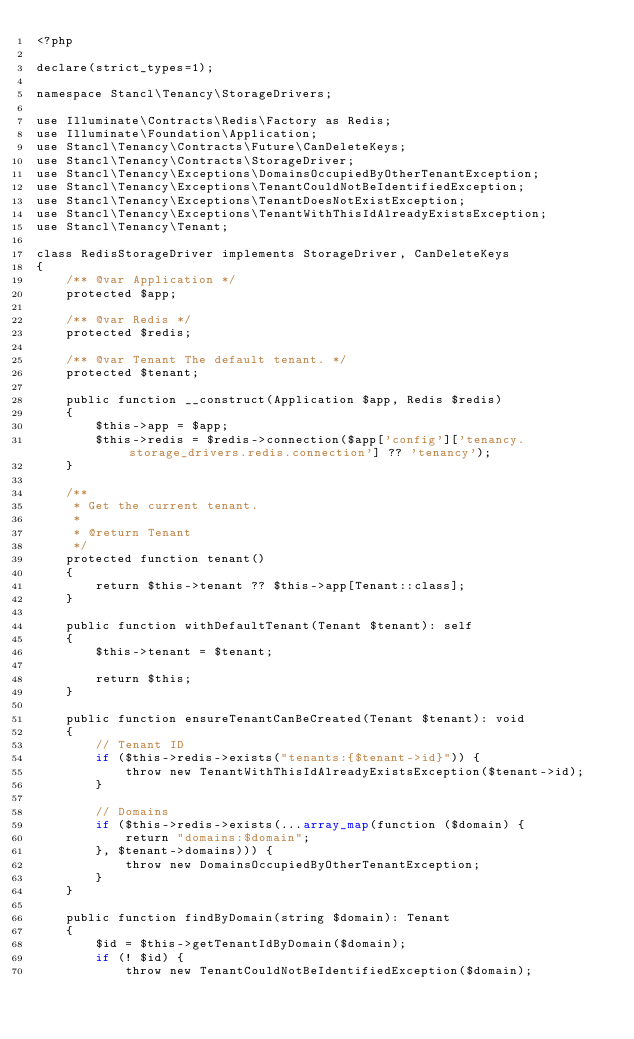<code> <loc_0><loc_0><loc_500><loc_500><_PHP_><?php

declare(strict_types=1);

namespace Stancl\Tenancy\StorageDrivers;

use Illuminate\Contracts\Redis\Factory as Redis;
use Illuminate\Foundation\Application;
use Stancl\Tenancy\Contracts\Future\CanDeleteKeys;
use Stancl\Tenancy\Contracts\StorageDriver;
use Stancl\Tenancy\Exceptions\DomainsOccupiedByOtherTenantException;
use Stancl\Tenancy\Exceptions\TenantCouldNotBeIdentifiedException;
use Stancl\Tenancy\Exceptions\TenantDoesNotExistException;
use Stancl\Tenancy\Exceptions\TenantWithThisIdAlreadyExistsException;
use Stancl\Tenancy\Tenant;

class RedisStorageDriver implements StorageDriver, CanDeleteKeys
{
    /** @var Application */
    protected $app;

    /** @var Redis */
    protected $redis;

    /** @var Tenant The default tenant. */
    protected $tenant;

    public function __construct(Application $app, Redis $redis)
    {
        $this->app = $app;
        $this->redis = $redis->connection($app['config']['tenancy.storage_drivers.redis.connection'] ?? 'tenancy');
    }

    /**
     * Get the current tenant.
     *
     * @return Tenant
     */
    protected function tenant()
    {
        return $this->tenant ?? $this->app[Tenant::class];
    }

    public function withDefaultTenant(Tenant $tenant): self
    {
        $this->tenant = $tenant;

        return $this;
    }

    public function ensureTenantCanBeCreated(Tenant $tenant): void
    {
        // Tenant ID
        if ($this->redis->exists("tenants:{$tenant->id}")) {
            throw new TenantWithThisIdAlreadyExistsException($tenant->id);
        }

        // Domains
        if ($this->redis->exists(...array_map(function ($domain) {
            return "domains:$domain";
        }, $tenant->domains))) {
            throw new DomainsOccupiedByOtherTenantException;
        }
    }

    public function findByDomain(string $domain): Tenant
    {
        $id = $this->getTenantIdByDomain($domain);
        if (! $id) {
            throw new TenantCouldNotBeIdentifiedException($domain);</code> 